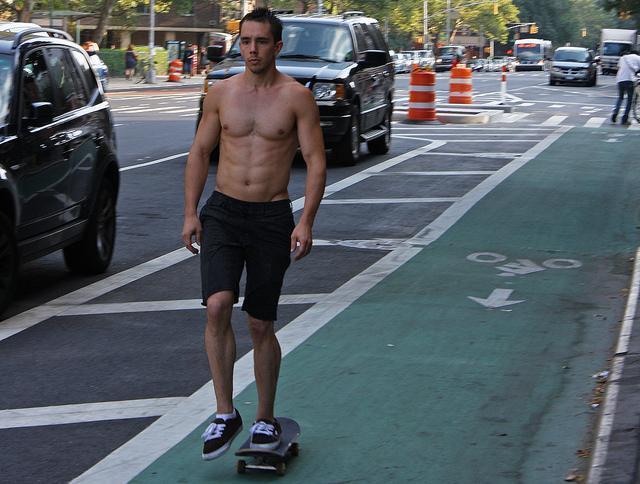How many trucks are visible?
Give a very brief answer. 2. 